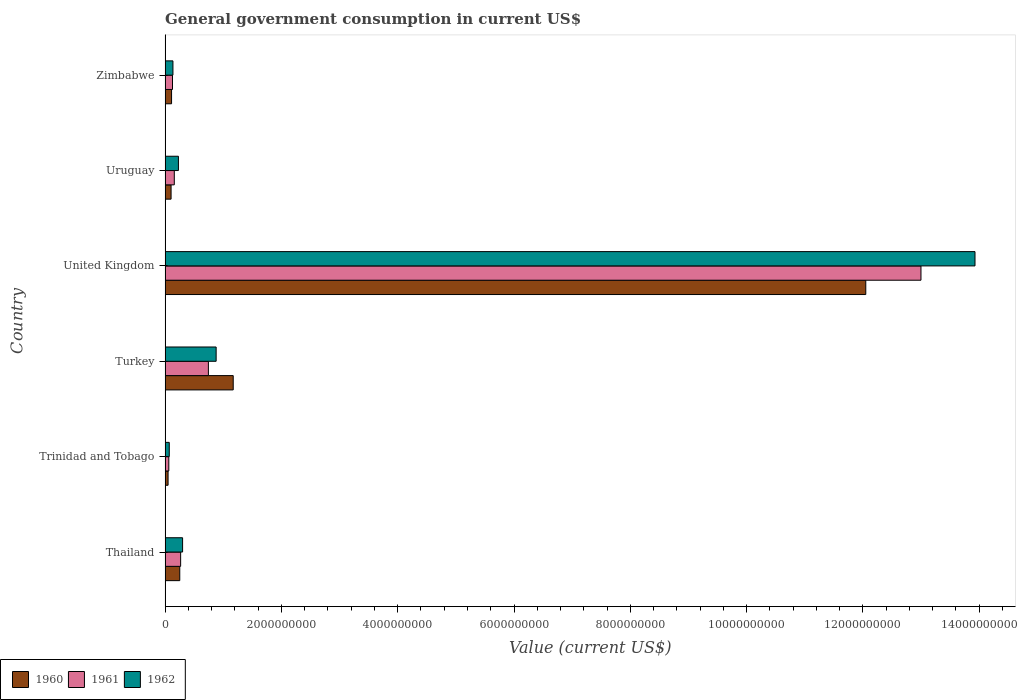How many groups of bars are there?
Your response must be concise. 6. Are the number of bars per tick equal to the number of legend labels?
Give a very brief answer. Yes. What is the label of the 5th group of bars from the top?
Make the answer very short. Trinidad and Tobago. What is the government conusmption in 1960 in Zimbabwe?
Give a very brief answer. 1.11e+08. Across all countries, what is the maximum government conusmption in 1961?
Your answer should be compact. 1.30e+1. Across all countries, what is the minimum government conusmption in 1962?
Your answer should be very brief. 7.16e+07. In which country was the government conusmption in 1960 minimum?
Provide a short and direct response. Trinidad and Tobago. What is the total government conusmption in 1962 in the graph?
Your answer should be very brief. 1.55e+1. What is the difference between the government conusmption in 1961 in Thailand and that in Zimbabwe?
Offer a terse response. 1.40e+08. What is the difference between the government conusmption in 1962 in Trinidad and Tobago and the government conusmption in 1960 in Uruguay?
Your answer should be very brief. -3.12e+07. What is the average government conusmption in 1961 per country?
Make the answer very short. 2.39e+09. What is the difference between the government conusmption in 1961 and government conusmption in 1960 in Uruguay?
Offer a very short reply. 5.54e+07. In how many countries, is the government conusmption in 1962 greater than 6400000000 US$?
Your answer should be compact. 1. What is the ratio of the government conusmption in 1961 in United Kingdom to that in Uruguay?
Make the answer very short. 82.14. Is the government conusmption in 1960 in Turkey less than that in United Kingdom?
Your answer should be very brief. Yes. Is the difference between the government conusmption in 1961 in Thailand and Zimbabwe greater than the difference between the government conusmption in 1960 in Thailand and Zimbabwe?
Give a very brief answer. No. What is the difference between the highest and the second highest government conusmption in 1961?
Offer a terse response. 1.23e+1. What is the difference between the highest and the lowest government conusmption in 1961?
Offer a terse response. 1.29e+1. Is the sum of the government conusmption in 1961 in Thailand and Zimbabwe greater than the maximum government conusmption in 1960 across all countries?
Provide a short and direct response. No. What does the 1st bar from the bottom in United Kingdom represents?
Ensure brevity in your answer.  1960. Is it the case that in every country, the sum of the government conusmption in 1960 and government conusmption in 1961 is greater than the government conusmption in 1962?
Offer a terse response. Yes. How many bars are there?
Ensure brevity in your answer.  18. How many countries are there in the graph?
Offer a terse response. 6. Does the graph contain grids?
Offer a terse response. No. Where does the legend appear in the graph?
Your answer should be very brief. Bottom left. How many legend labels are there?
Offer a very short reply. 3. What is the title of the graph?
Offer a very short reply. General government consumption in current US$. What is the label or title of the X-axis?
Your answer should be very brief. Value (current US$). What is the Value (current US$) in 1960 in Thailand?
Your response must be concise. 2.52e+08. What is the Value (current US$) in 1961 in Thailand?
Provide a short and direct response. 2.67e+08. What is the Value (current US$) in 1962 in Thailand?
Your answer should be compact. 3.01e+08. What is the Value (current US$) of 1960 in Trinidad and Tobago?
Your response must be concise. 5.12e+07. What is the Value (current US$) of 1961 in Trinidad and Tobago?
Give a very brief answer. 6.39e+07. What is the Value (current US$) of 1962 in Trinidad and Tobago?
Your response must be concise. 7.16e+07. What is the Value (current US$) in 1960 in Turkey?
Make the answer very short. 1.17e+09. What is the Value (current US$) in 1961 in Turkey?
Make the answer very short. 7.44e+08. What is the Value (current US$) of 1962 in Turkey?
Provide a succinct answer. 8.78e+08. What is the Value (current US$) in 1960 in United Kingdom?
Ensure brevity in your answer.  1.20e+1. What is the Value (current US$) of 1961 in United Kingdom?
Give a very brief answer. 1.30e+1. What is the Value (current US$) of 1962 in United Kingdom?
Offer a very short reply. 1.39e+1. What is the Value (current US$) of 1960 in Uruguay?
Your answer should be very brief. 1.03e+08. What is the Value (current US$) of 1961 in Uruguay?
Give a very brief answer. 1.58e+08. What is the Value (current US$) in 1962 in Uruguay?
Provide a succinct answer. 2.29e+08. What is the Value (current US$) in 1960 in Zimbabwe?
Give a very brief answer. 1.11e+08. What is the Value (current US$) in 1961 in Zimbabwe?
Make the answer very short. 1.27e+08. What is the Value (current US$) in 1962 in Zimbabwe?
Provide a succinct answer. 1.35e+08. Across all countries, what is the maximum Value (current US$) in 1960?
Provide a succinct answer. 1.20e+1. Across all countries, what is the maximum Value (current US$) of 1961?
Your response must be concise. 1.30e+1. Across all countries, what is the maximum Value (current US$) of 1962?
Your response must be concise. 1.39e+1. Across all countries, what is the minimum Value (current US$) in 1960?
Your answer should be compact. 5.12e+07. Across all countries, what is the minimum Value (current US$) in 1961?
Provide a succinct answer. 6.39e+07. Across all countries, what is the minimum Value (current US$) in 1962?
Provide a succinct answer. 7.16e+07. What is the total Value (current US$) in 1960 in the graph?
Offer a very short reply. 1.37e+1. What is the total Value (current US$) of 1961 in the graph?
Your answer should be compact. 1.44e+1. What is the total Value (current US$) of 1962 in the graph?
Your response must be concise. 1.55e+1. What is the difference between the Value (current US$) in 1960 in Thailand and that in Trinidad and Tobago?
Provide a short and direct response. 2.01e+08. What is the difference between the Value (current US$) of 1961 in Thailand and that in Trinidad and Tobago?
Offer a very short reply. 2.03e+08. What is the difference between the Value (current US$) of 1962 in Thailand and that in Trinidad and Tobago?
Give a very brief answer. 2.29e+08. What is the difference between the Value (current US$) in 1960 in Thailand and that in Turkey?
Your answer should be very brief. -9.19e+08. What is the difference between the Value (current US$) in 1961 in Thailand and that in Turkey?
Offer a very short reply. -4.77e+08. What is the difference between the Value (current US$) of 1962 in Thailand and that in Turkey?
Make the answer very short. -5.77e+08. What is the difference between the Value (current US$) in 1960 in Thailand and that in United Kingdom?
Offer a terse response. -1.18e+1. What is the difference between the Value (current US$) of 1961 in Thailand and that in United Kingdom?
Offer a terse response. -1.27e+1. What is the difference between the Value (current US$) of 1962 in Thailand and that in United Kingdom?
Keep it short and to the point. -1.36e+1. What is the difference between the Value (current US$) in 1960 in Thailand and that in Uruguay?
Provide a short and direct response. 1.49e+08. What is the difference between the Value (current US$) of 1961 in Thailand and that in Uruguay?
Keep it short and to the point. 1.09e+08. What is the difference between the Value (current US$) in 1962 in Thailand and that in Uruguay?
Make the answer very short. 7.16e+07. What is the difference between the Value (current US$) of 1960 in Thailand and that in Zimbabwe?
Provide a succinct answer. 1.41e+08. What is the difference between the Value (current US$) of 1961 in Thailand and that in Zimbabwe?
Give a very brief answer. 1.40e+08. What is the difference between the Value (current US$) in 1962 in Thailand and that in Zimbabwe?
Offer a very short reply. 1.66e+08. What is the difference between the Value (current US$) in 1960 in Trinidad and Tobago and that in Turkey?
Provide a succinct answer. -1.12e+09. What is the difference between the Value (current US$) in 1961 in Trinidad and Tobago and that in Turkey?
Offer a very short reply. -6.81e+08. What is the difference between the Value (current US$) of 1962 in Trinidad and Tobago and that in Turkey?
Provide a succinct answer. -8.06e+08. What is the difference between the Value (current US$) of 1960 in Trinidad and Tobago and that in United Kingdom?
Offer a terse response. -1.20e+1. What is the difference between the Value (current US$) of 1961 in Trinidad and Tobago and that in United Kingdom?
Your answer should be very brief. -1.29e+1. What is the difference between the Value (current US$) of 1962 in Trinidad and Tobago and that in United Kingdom?
Your response must be concise. -1.39e+1. What is the difference between the Value (current US$) of 1960 in Trinidad and Tobago and that in Uruguay?
Offer a very short reply. -5.16e+07. What is the difference between the Value (current US$) in 1961 in Trinidad and Tobago and that in Uruguay?
Your answer should be compact. -9.44e+07. What is the difference between the Value (current US$) in 1962 in Trinidad and Tobago and that in Uruguay?
Offer a terse response. -1.58e+08. What is the difference between the Value (current US$) in 1960 in Trinidad and Tobago and that in Zimbabwe?
Offer a very short reply. -5.99e+07. What is the difference between the Value (current US$) of 1961 in Trinidad and Tobago and that in Zimbabwe?
Your answer should be compact. -6.35e+07. What is the difference between the Value (current US$) in 1962 in Trinidad and Tobago and that in Zimbabwe?
Provide a short and direct response. -6.32e+07. What is the difference between the Value (current US$) in 1960 in Turkey and that in United Kingdom?
Your answer should be compact. -1.09e+1. What is the difference between the Value (current US$) of 1961 in Turkey and that in United Kingdom?
Offer a terse response. -1.23e+1. What is the difference between the Value (current US$) of 1962 in Turkey and that in United Kingdom?
Keep it short and to the point. -1.30e+1. What is the difference between the Value (current US$) of 1960 in Turkey and that in Uruguay?
Keep it short and to the point. 1.07e+09. What is the difference between the Value (current US$) of 1961 in Turkey and that in Uruguay?
Your answer should be very brief. 5.86e+08. What is the difference between the Value (current US$) of 1962 in Turkey and that in Uruguay?
Your answer should be compact. 6.49e+08. What is the difference between the Value (current US$) in 1960 in Turkey and that in Zimbabwe?
Ensure brevity in your answer.  1.06e+09. What is the difference between the Value (current US$) in 1961 in Turkey and that in Zimbabwe?
Provide a short and direct response. 6.17e+08. What is the difference between the Value (current US$) in 1962 in Turkey and that in Zimbabwe?
Ensure brevity in your answer.  7.43e+08. What is the difference between the Value (current US$) of 1960 in United Kingdom and that in Uruguay?
Your answer should be very brief. 1.19e+1. What is the difference between the Value (current US$) of 1961 in United Kingdom and that in Uruguay?
Provide a succinct answer. 1.28e+1. What is the difference between the Value (current US$) of 1962 in United Kingdom and that in Uruguay?
Make the answer very short. 1.37e+1. What is the difference between the Value (current US$) of 1960 in United Kingdom and that in Zimbabwe?
Provide a succinct answer. 1.19e+1. What is the difference between the Value (current US$) of 1961 in United Kingdom and that in Zimbabwe?
Keep it short and to the point. 1.29e+1. What is the difference between the Value (current US$) of 1962 in United Kingdom and that in Zimbabwe?
Your answer should be compact. 1.38e+1. What is the difference between the Value (current US$) of 1960 in Uruguay and that in Zimbabwe?
Give a very brief answer. -8.26e+06. What is the difference between the Value (current US$) in 1961 in Uruguay and that in Zimbabwe?
Offer a terse response. 3.09e+07. What is the difference between the Value (current US$) in 1962 in Uruguay and that in Zimbabwe?
Your response must be concise. 9.44e+07. What is the difference between the Value (current US$) in 1960 in Thailand and the Value (current US$) in 1961 in Trinidad and Tobago?
Provide a short and direct response. 1.88e+08. What is the difference between the Value (current US$) of 1960 in Thailand and the Value (current US$) of 1962 in Trinidad and Tobago?
Keep it short and to the point. 1.81e+08. What is the difference between the Value (current US$) of 1961 in Thailand and the Value (current US$) of 1962 in Trinidad and Tobago?
Provide a succinct answer. 1.96e+08. What is the difference between the Value (current US$) of 1960 in Thailand and the Value (current US$) of 1961 in Turkey?
Offer a terse response. -4.92e+08. What is the difference between the Value (current US$) of 1960 in Thailand and the Value (current US$) of 1962 in Turkey?
Provide a succinct answer. -6.26e+08. What is the difference between the Value (current US$) in 1961 in Thailand and the Value (current US$) in 1962 in Turkey?
Your response must be concise. -6.11e+08. What is the difference between the Value (current US$) in 1960 in Thailand and the Value (current US$) in 1961 in United Kingdom?
Your response must be concise. -1.27e+1. What is the difference between the Value (current US$) of 1960 in Thailand and the Value (current US$) of 1962 in United Kingdom?
Provide a succinct answer. -1.37e+1. What is the difference between the Value (current US$) of 1961 in Thailand and the Value (current US$) of 1962 in United Kingdom?
Your answer should be very brief. -1.37e+1. What is the difference between the Value (current US$) of 1960 in Thailand and the Value (current US$) of 1961 in Uruguay?
Your answer should be very brief. 9.39e+07. What is the difference between the Value (current US$) in 1960 in Thailand and the Value (current US$) in 1962 in Uruguay?
Offer a terse response. 2.30e+07. What is the difference between the Value (current US$) in 1961 in Thailand and the Value (current US$) in 1962 in Uruguay?
Your answer should be compact. 3.80e+07. What is the difference between the Value (current US$) in 1960 in Thailand and the Value (current US$) in 1961 in Zimbabwe?
Your answer should be very brief. 1.25e+08. What is the difference between the Value (current US$) in 1960 in Thailand and the Value (current US$) in 1962 in Zimbabwe?
Offer a terse response. 1.17e+08. What is the difference between the Value (current US$) in 1961 in Thailand and the Value (current US$) in 1962 in Zimbabwe?
Provide a succinct answer. 1.32e+08. What is the difference between the Value (current US$) of 1960 in Trinidad and Tobago and the Value (current US$) of 1961 in Turkey?
Keep it short and to the point. -6.93e+08. What is the difference between the Value (current US$) of 1960 in Trinidad and Tobago and the Value (current US$) of 1962 in Turkey?
Offer a terse response. -8.27e+08. What is the difference between the Value (current US$) in 1961 in Trinidad and Tobago and the Value (current US$) in 1962 in Turkey?
Provide a succinct answer. -8.14e+08. What is the difference between the Value (current US$) in 1960 in Trinidad and Tobago and the Value (current US$) in 1961 in United Kingdom?
Offer a terse response. -1.29e+1. What is the difference between the Value (current US$) in 1960 in Trinidad and Tobago and the Value (current US$) in 1962 in United Kingdom?
Provide a succinct answer. -1.39e+1. What is the difference between the Value (current US$) of 1961 in Trinidad and Tobago and the Value (current US$) of 1962 in United Kingdom?
Offer a terse response. -1.39e+1. What is the difference between the Value (current US$) of 1960 in Trinidad and Tobago and the Value (current US$) of 1961 in Uruguay?
Provide a succinct answer. -1.07e+08. What is the difference between the Value (current US$) of 1960 in Trinidad and Tobago and the Value (current US$) of 1962 in Uruguay?
Make the answer very short. -1.78e+08. What is the difference between the Value (current US$) of 1961 in Trinidad and Tobago and the Value (current US$) of 1962 in Uruguay?
Your response must be concise. -1.65e+08. What is the difference between the Value (current US$) of 1960 in Trinidad and Tobago and the Value (current US$) of 1961 in Zimbabwe?
Offer a very short reply. -7.61e+07. What is the difference between the Value (current US$) of 1960 in Trinidad and Tobago and the Value (current US$) of 1962 in Zimbabwe?
Keep it short and to the point. -8.35e+07. What is the difference between the Value (current US$) in 1961 in Trinidad and Tobago and the Value (current US$) in 1962 in Zimbabwe?
Provide a short and direct response. -7.09e+07. What is the difference between the Value (current US$) in 1960 in Turkey and the Value (current US$) in 1961 in United Kingdom?
Provide a succinct answer. -1.18e+1. What is the difference between the Value (current US$) of 1960 in Turkey and the Value (current US$) of 1962 in United Kingdom?
Keep it short and to the point. -1.28e+1. What is the difference between the Value (current US$) of 1961 in Turkey and the Value (current US$) of 1962 in United Kingdom?
Provide a succinct answer. -1.32e+1. What is the difference between the Value (current US$) in 1960 in Turkey and the Value (current US$) in 1961 in Uruguay?
Offer a terse response. 1.01e+09. What is the difference between the Value (current US$) of 1960 in Turkey and the Value (current US$) of 1962 in Uruguay?
Provide a short and direct response. 9.42e+08. What is the difference between the Value (current US$) in 1961 in Turkey and the Value (current US$) in 1962 in Uruguay?
Your response must be concise. 5.15e+08. What is the difference between the Value (current US$) of 1960 in Turkey and the Value (current US$) of 1961 in Zimbabwe?
Provide a short and direct response. 1.04e+09. What is the difference between the Value (current US$) in 1960 in Turkey and the Value (current US$) in 1962 in Zimbabwe?
Your response must be concise. 1.04e+09. What is the difference between the Value (current US$) in 1961 in Turkey and the Value (current US$) in 1962 in Zimbabwe?
Provide a short and direct response. 6.10e+08. What is the difference between the Value (current US$) of 1960 in United Kingdom and the Value (current US$) of 1961 in Uruguay?
Keep it short and to the point. 1.19e+1. What is the difference between the Value (current US$) of 1960 in United Kingdom and the Value (current US$) of 1962 in Uruguay?
Your response must be concise. 1.18e+1. What is the difference between the Value (current US$) of 1961 in United Kingdom and the Value (current US$) of 1962 in Uruguay?
Offer a terse response. 1.28e+1. What is the difference between the Value (current US$) in 1960 in United Kingdom and the Value (current US$) in 1961 in Zimbabwe?
Provide a succinct answer. 1.19e+1. What is the difference between the Value (current US$) of 1960 in United Kingdom and the Value (current US$) of 1962 in Zimbabwe?
Ensure brevity in your answer.  1.19e+1. What is the difference between the Value (current US$) in 1961 in United Kingdom and the Value (current US$) in 1962 in Zimbabwe?
Make the answer very short. 1.29e+1. What is the difference between the Value (current US$) of 1960 in Uruguay and the Value (current US$) of 1961 in Zimbabwe?
Ensure brevity in your answer.  -2.45e+07. What is the difference between the Value (current US$) of 1960 in Uruguay and the Value (current US$) of 1962 in Zimbabwe?
Ensure brevity in your answer.  -3.19e+07. What is the difference between the Value (current US$) in 1961 in Uruguay and the Value (current US$) in 1962 in Zimbabwe?
Offer a very short reply. 2.35e+07. What is the average Value (current US$) in 1960 per country?
Provide a succinct answer. 2.29e+09. What is the average Value (current US$) of 1961 per country?
Your answer should be compact. 2.39e+09. What is the average Value (current US$) of 1962 per country?
Provide a succinct answer. 2.59e+09. What is the difference between the Value (current US$) of 1960 and Value (current US$) of 1961 in Thailand?
Your answer should be compact. -1.50e+07. What is the difference between the Value (current US$) in 1960 and Value (current US$) in 1962 in Thailand?
Provide a succinct answer. -4.86e+07. What is the difference between the Value (current US$) in 1961 and Value (current US$) in 1962 in Thailand?
Your response must be concise. -3.36e+07. What is the difference between the Value (current US$) of 1960 and Value (current US$) of 1961 in Trinidad and Tobago?
Keep it short and to the point. -1.27e+07. What is the difference between the Value (current US$) in 1960 and Value (current US$) in 1962 in Trinidad and Tobago?
Your answer should be very brief. -2.04e+07. What is the difference between the Value (current US$) of 1961 and Value (current US$) of 1962 in Trinidad and Tobago?
Provide a short and direct response. -7.70e+06. What is the difference between the Value (current US$) of 1960 and Value (current US$) of 1961 in Turkey?
Your answer should be very brief. 4.27e+08. What is the difference between the Value (current US$) in 1960 and Value (current US$) in 1962 in Turkey?
Your answer should be compact. 2.94e+08. What is the difference between the Value (current US$) in 1961 and Value (current US$) in 1962 in Turkey?
Provide a succinct answer. -1.33e+08. What is the difference between the Value (current US$) in 1960 and Value (current US$) in 1961 in United Kingdom?
Keep it short and to the point. -9.49e+08. What is the difference between the Value (current US$) in 1960 and Value (current US$) in 1962 in United Kingdom?
Your answer should be compact. -1.88e+09. What is the difference between the Value (current US$) of 1961 and Value (current US$) of 1962 in United Kingdom?
Provide a succinct answer. -9.29e+08. What is the difference between the Value (current US$) in 1960 and Value (current US$) in 1961 in Uruguay?
Give a very brief answer. -5.54e+07. What is the difference between the Value (current US$) in 1960 and Value (current US$) in 1962 in Uruguay?
Ensure brevity in your answer.  -1.26e+08. What is the difference between the Value (current US$) in 1961 and Value (current US$) in 1962 in Uruguay?
Make the answer very short. -7.09e+07. What is the difference between the Value (current US$) in 1960 and Value (current US$) in 1961 in Zimbabwe?
Give a very brief answer. -1.63e+07. What is the difference between the Value (current US$) in 1960 and Value (current US$) in 1962 in Zimbabwe?
Keep it short and to the point. -2.37e+07. What is the difference between the Value (current US$) in 1961 and Value (current US$) in 1962 in Zimbabwe?
Offer a terse response. -7.39e+06. What is the ratio of the Value (current US$) in 1960 in Thailand to that in Trinidad and Tobago?
Offer a terse response. 4.92. What is the ratio of the Value (current US$) of 1961 in Thailand to that in Trinidad and Tobago?
Provide a short and direct response. 4.18. What is the ratio of the Value (current US$) of 1962 in Thailand to that in Trinidad and Tobago?
Provide a succinct answer. 4.2. What is the ratio of the Value (current US$) in 1960 in Thailand to that in Turkey?
Provide a short and direct response. 0.22. What is the ratio of the Value (current US$) in 1961 in Thailand to that in Turkey?
Provide a short and direct response. 0.36. What is the ratio of the Value (current US$) of 1962 in Thailand to that in Turkey?
Ensure brevity in your answer.  0.34. What is the ratio of the Value (current US$) of 1960 in Thailand to that in United Kingdom?
Your answer should be compact. 0.02. What is the ratio of the Value (current US$) of 1961 in Thailand to that in United Kingdom?
Your answer should be compact. 0.02. What is the ratio of the Value (current US$) in 1962 in Thailand to that in United Kingdom?
Your response must be concise. 0.02. What is the ratio of the Value (current US$) in 1960 in Thailand to that in Uruguay?
Make the answer very short. 2.45. What is the ratio of the Value (current US$) of 1961 in Thailand to that in Uruguay?
Provide a short and direct response. 1.69. What is the ratio of the Value (current US$) in 1962 in Thailand to that in Uruguay?
Give a very brief answer. 1.31. What is the ratio of the Value (current US$) in 1960 in Thailand to that in Zimbabwe?
Keep it short and to the point. 2.27. What is the ratio of the Value (current US$) of 1961 in Thailand to that in Zimbabwe?
Offer a very short reply. 2.1. What is the ratio of the Value (current US$) of 1962 in Thailand to that in Zimbabwe?
Offer a very short reply. 2.23. What is the ratio of the Value (current US$) of 1960 in Trinidad and Tobago to that in Turkey?
Make the answer very short. 0.04. What is the ratio of the Value (current US$) of 1961 in Trinidad and Tobago to that in Turkey?
Keep it short and to the point. 0.09. What is the ratio of the Value (current US$) in 1962 in Trinidad and Tobago to that in Turkey?
Make the answer very short. 0.08. What is the ratio of the Value (current US$) of 1960 in Trinidad and Tobago to that in United Kingdom?
Your answer should be very brief. 0. What is the ratio of the Value (current US$) in 1961 in Trinidad and Tobago to that in United Kingdom?
Ensure brevity in your answer.  0. What is the ratio of the Value (current US$) in 1962 in Trinidad and Tobago to that in United Kingdom?
Offer a terse response. 0.01. What is the ratio of the Value (current US$) of 1960 in Trinidad and Tobago to that in Uruguay?
Provide a succinct answer. 0.5. What is the ratio of the Value (current US$) of 1961 in Trinidad and Tobago to that in Uruguay?
Keep it short and to the point. 0.4. What is the ratio of the Value (current US$) in 1962 in Trinidad and Tobago to that in Uruguay?
Your answer should be very brief. 0.31. What is the ratio of the Value (current US$) of 1960 in Trinidad and Tobago to that in Zimbabwe?
Your answer should be very brief. 0.46. What is the ratio of the Value (current US$) of 1961 in Trinidad and Tobago to that in Zimbabwe?
Offer a very short reply. 0.5. What is the ratio of the Value (current US$) in 1962 in Trinidad and Tobago to that in Zimbabwe?
Provide a succinct answer. 0.53. What is the ratio of the Value (current US$) in 1960 in Turkey to that in United Kingdom?
Offer a very short reply. 0.1. What is the ratio of the Value (current US$) in 1961 in Turkey to that in United Kingdom?
Your answer should be very brief. 0.06. What is the ratio of the Value (current US$) of 1962 in Turkey to that in United Kingdom?
Keep it short and to the point. 0.06. What is the ratio of the Value (current US$) in 1960 in Turkey to that in Uruguay?
Your response must be concise. 11.39. What is the ratio of the Value (current US$) of 1961 in Turkey to that in Uruguay?
Ensure brevity in your answer.  4.7. What is the ratio of the Value (current US$) in 1962 in Turkey to that in Uruguay?
Ensure brevity in your answer.  3.83. What is the ratio of the Value (current US$) of 1960 in Turkey to that in Zimbabwe?
Your answer should be compact. 10.55. What is the ratio of the Value (current US$) in 1961 in Turkey to that in Zimbabwe?
Give a very brief answer. 5.85. What is the ratio of the Value (current US$) in 1962 in Turkey to that in Zimbabwe?
Provide a succinct answer. 6.52. What is the ratio of the Value (current US$) in 1960 in United Kingdom to that in Uruguay?
Give a very brief answer. 117.2. What is the ratio of the Value (current US$) in 1961 in United Kingdom to that in Uruguay?
Provide a short and direct response. 82.14. What is the ratio of the Value (current US$) of 1962 in United Kingdom to that in Uruguay?
Give a very brief answer. 60.77. What is the ratio of the Value (current US$) in 1960 in United Kingdom to that in Zimbabwe?
Offer a very short reply. 108.49. What is the ratio of the Value (current US$) in 1961 in United Kingdom to that in Zimbabwe?
Make the answer very short. 102.08. What is the ratio of the Value (current US$) of 1962 in United Kingdom to that in Zimbabwe?
Your answer should be very brief. 103.37. What is the ratio of the Value (current US$) of 1960 in Uruguay to that in Zimbabwe?
Your response must be concise. 0.93. What is the ratio of the Value (current US$) in 1961 in Uruguay to that in Zimbabwe?
Provide a succinct answer. 1.24. What is the ratio of the Value (current US$) in 1962 in Uruguay to that in Zimbabwe?
Give a very brief answer. 1.7. What is the difference between the highest and the second highest Value (current US$) of 1960?
Offer a terse response. 1.09e+1. What is the difference between the highest and the second highest Value (current US$) of 1961?
Ensure brevity in your answer.  1.23e+1. What is the difference between the highest and the second highest Value (current US$) of 1962?
Provide a succinct answer. 1.30e+1. What is the difference between the highest and the lowest Value (current US$) of 1960?
Your response must be concise. 1.20e+1. What is the difference between the highest and the lowest Value (current US$) in 1961?
Make the answer very short. 1.29e+1. What is the difference between the highest and the lowest Value (current US$) of 1962?
Keep it short and to the point. 1.39e+1. 